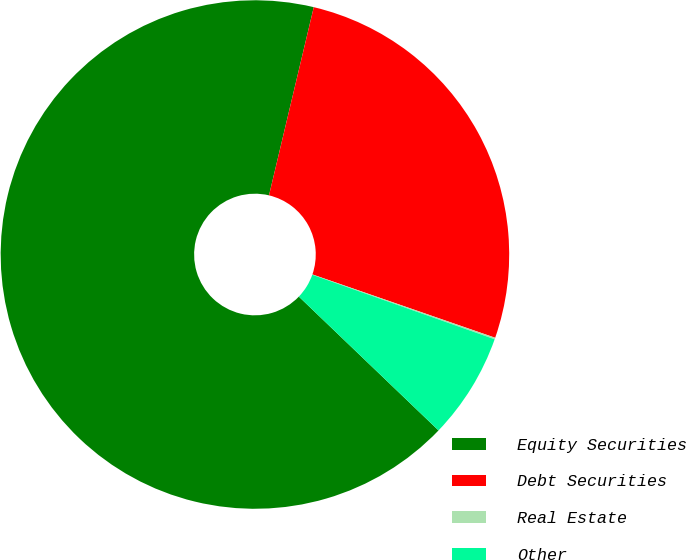Convert chart to OTSL. <chart><loc_0><loc_0><loc_500><loc_500><pie_chart><fcel>Equity Securities<fcel>Debt Securities<fcel>Real Estate<fcel>Other<nl><fcel>66.55%<fcel>26.59%<fcel>0.1%<fcel>6.75%<nl></chart> 